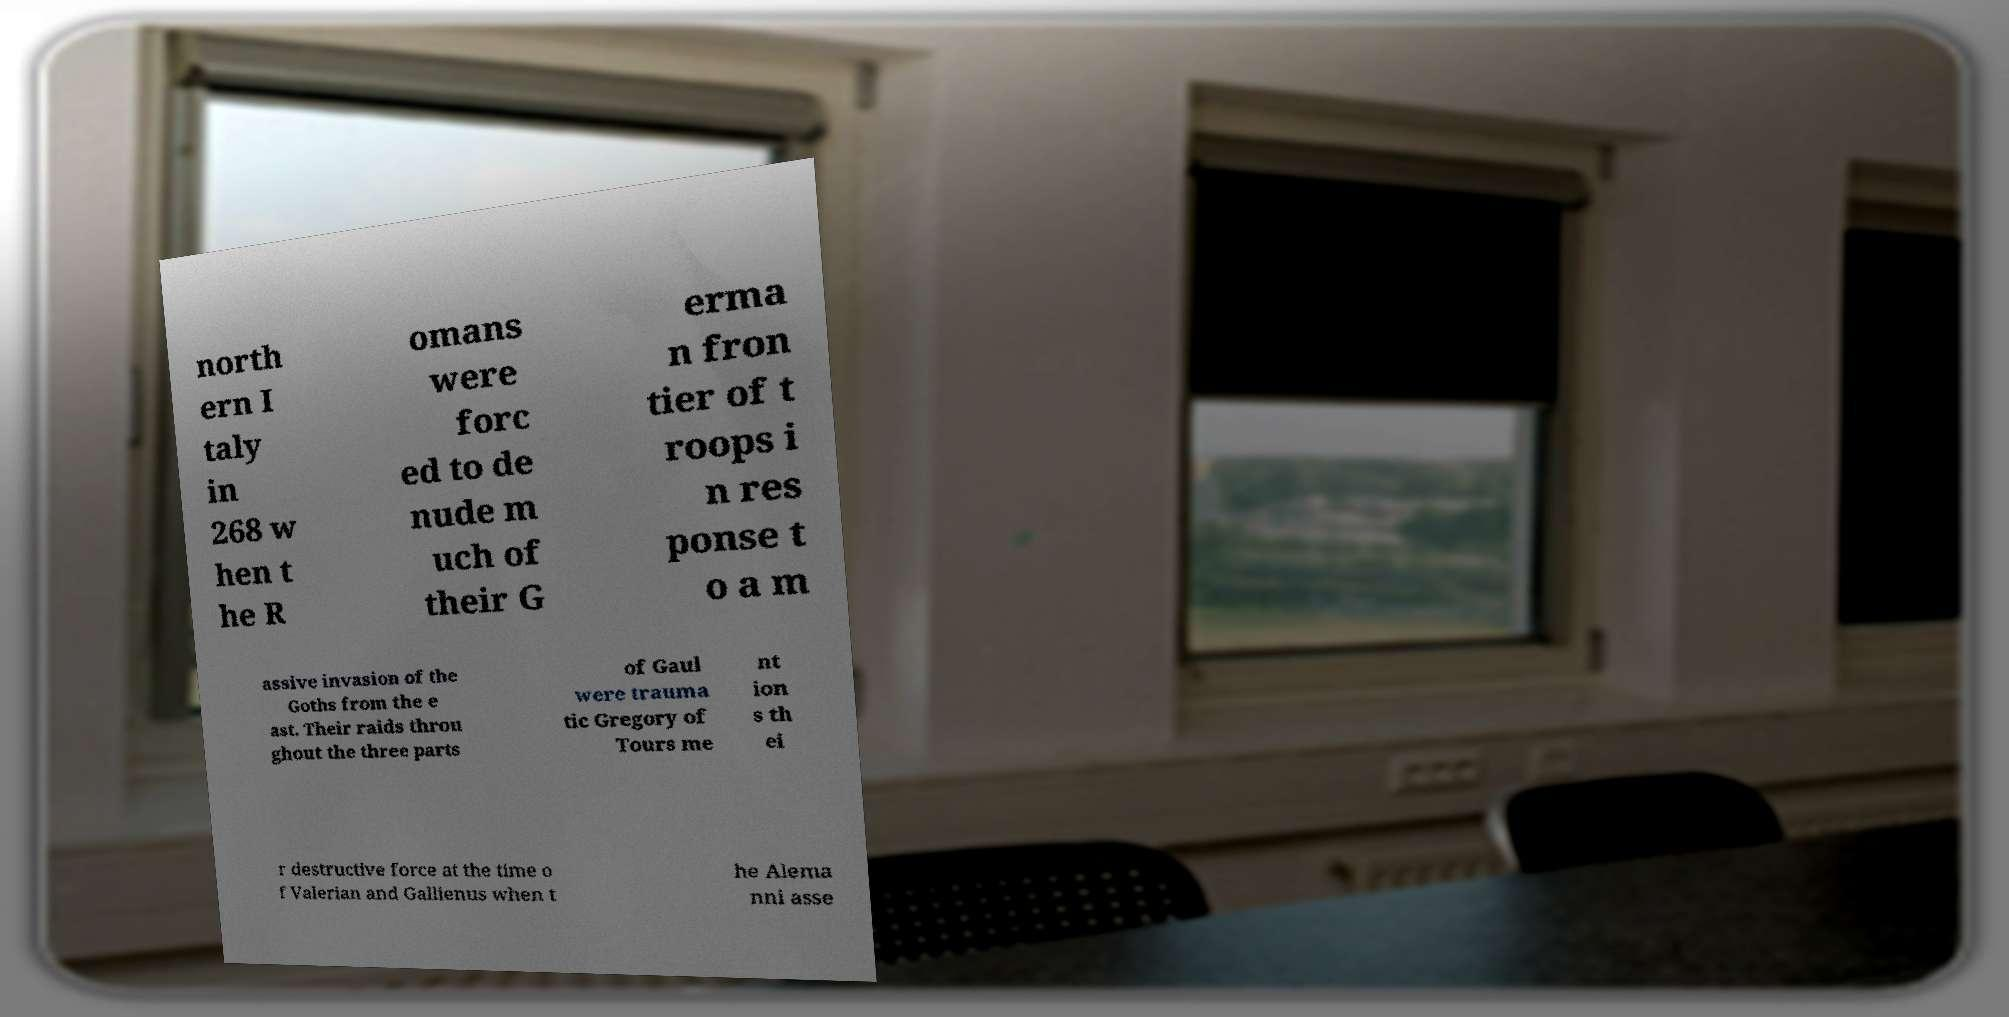Can you read and provide the text displayed in the image?This photo seems to have some interesting text. Can you extract and type it out for me? north ern I taly in 268 w hen t he R omans were forc ed to de nude m uch of their G erma n fron tier of t roops i n res ponse t o a m assive invasion of the Goths from the e ast. Their raids throu ghout the three parts of Gaul were trauma tic Gregory of Tours me nt ion s th ei r destructive force at the time o f Valerian and Gallienus when t he Alema nni asse 